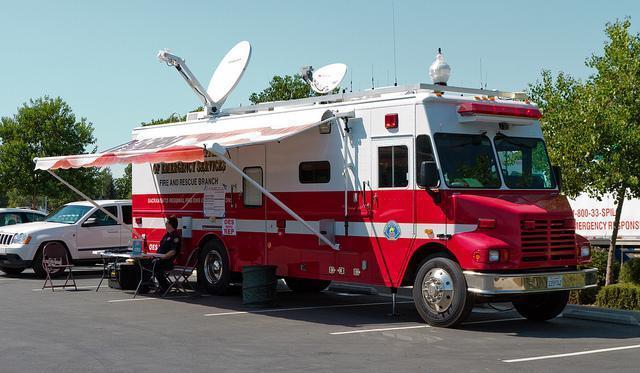How many satellites does this truck have?
Give a very brief answer. 2. How many trucks are in the picture?
Give a very brief answer. 2. 